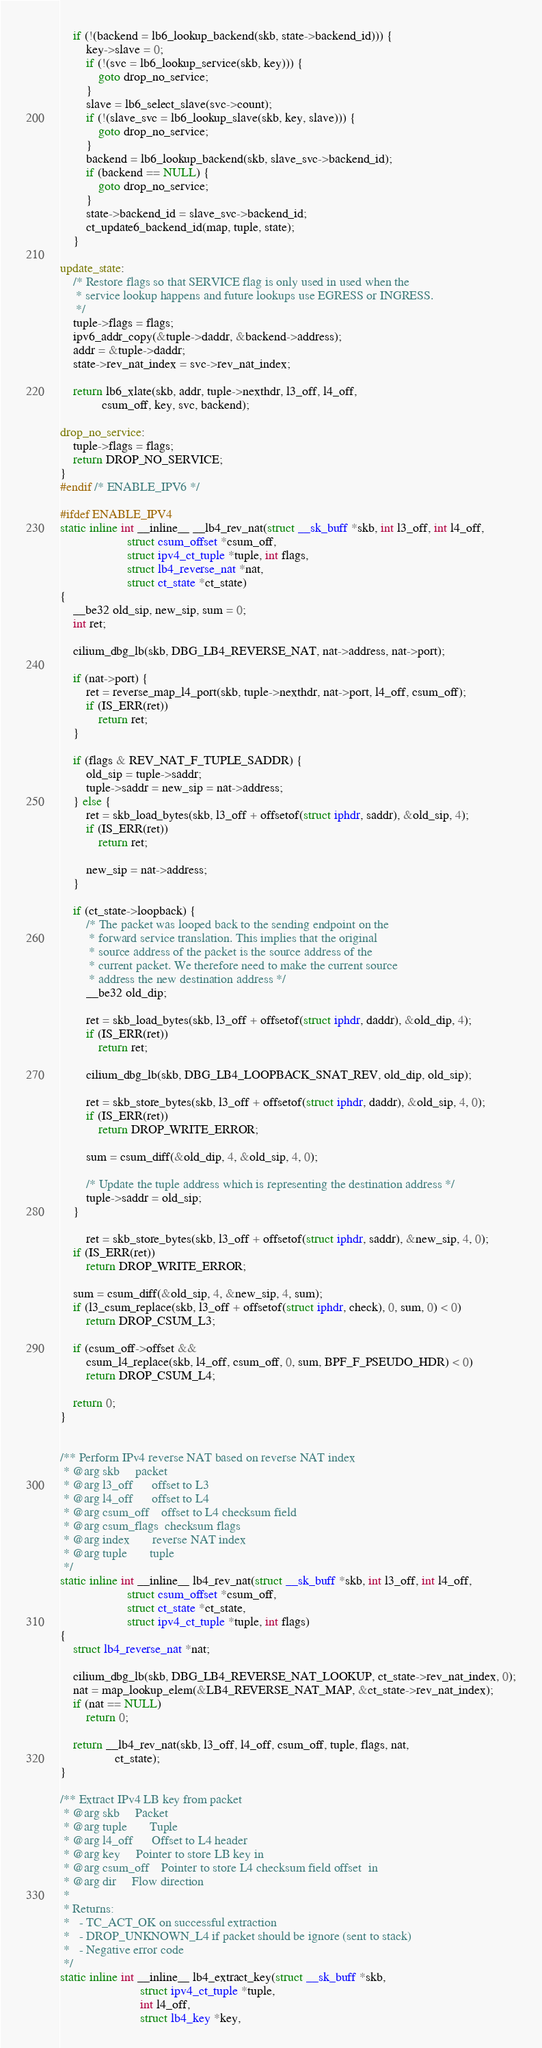<code> <loc_0><loc_0><loc_500><loc_500><_C_>	if (!(backend = lb6_lookup_backend(skb, state->backend_id))) {
		key->slave = 0;
		if (!(svc = lb6_lookup_service(skb, key))) {
			goto drop_no_service;
		}
		slave = lb6_select_slave(svc->count);
		if (!(slave_svc = lb6_lookup_slave(skb, key, slave))) {
			goto drop_no_service;
		}
		backend = lb6_lookup_backend(skb, slave_svc->backend_id);
		if (backend == NULL) {
			goto drop_no_service;
		}
		state->backend_id = slave_svc->backend_id;
		ct_update6_backend_id(map, tuple, state);
	}

update_state:
	/* Restore flags so that SERVICE flag is only used in used when the
	 * service lookup happens and future lookups use EGRESS or INGRESS.
	 */
	tuple->flags = flags;
	ipv6_addr_copy(&tuple->daddr, &backend->address);
	addr = &tuple->daddr;
	state->rev_nat_index = svc->rev_nat_index;

	return lb6_xlate(skb, addr, tuple->nexthdr, l3_off, l4_off,
			 csum_off, key, svc, backend);

drop_no_service:
	tuple->flags = flags;
	return DROP_NO_SERVICE;
}
#endif /* ENABLE_IPV6 */

#ifdef ENABLE_IPV4
static inline int __inline__ __lb4_rev_nat(struct __sk_buff *skb, int l3_off, int l4_off,
					 struct csum_offset *csum_off,
					 struct ipv4_ct_tuple *tuple, int flags,
					 struct lb4_reverse_nat *nat,
					 struct ct_state *ct_state)
{
	__be32 old_sip, new_sip, sum = 0;
	int ret;

	cilium_dbg_lb(skb, DBG_LB4_REVERSE_NAT, nat->address, nat->port);

	if (nat->port) {
		ret = reverse_map_l4_port(skb, tuple->nexthdr, nat->port, l4_off, csum_off);
		if (IS_ERR(ret))
			return ret;
	}

	if (flags & REV_NAT_F_TUPLE_SADDR) {
		old_sip = tuple->saddr;
		tuple->saddr = new_sip = nat->address;
	} else {
		ret = skb_load_bytes(skb, l3_off + offsetof(struct iphdr, saddr), &old_sip, 4);
		if (IS_ERR(ret))
			return ret;

		new_sip = nat->address;
	}

	if (ct_state->loopback) {
		/* The packet was looped back to the sending endpoint on the
		 * forward service translation. This implies that the original
		 * source address of the packet is the source address of the
		 * current packet. We therefore need to make the current source
		 * address the new destination address */
		__be32 old_dip;

		ret = skb_load_bytes(skb, l3_off + offsetof(struct iphdr, daddr), &old_dip, 4);
		if (IS_ERR(ret))
			return ret;

		cilium_dbg_lb(skb, DBG_LB4_LOOPBACK_SNAT_REV, old_dip, old_sip);

		ret = skb_store_bytes(skb, l3_off + offsetof(struct iphdr, daddr), &old_sip, 4, 0);
		if (IS_ERR(ret))
			return DROP_WRITE_ERROR;

		sum = csum_diff(&old_dip, 4, &old_sip, 4, 0);

		/* Update the tuple address which is representing the destination address */
		tuple->saddr = old_sip;
	}

        ret = skb_store_bytes(skb, l3_off + offsetof(struct iphdr, saddr), &new_sip, 4, 0);
	if (IS_ERR(ret))
		return DROP_WRITE_ERROR;

	sum = csum_diff(&old_sip, 4, &new_sip, 4, sum);
	if (l3_csum_replace(skb, l3_off + offsetof(struct iphdr, check), 0, sum, 0) < 0)
		return DROP_CSUM_L3;

	if (csum_off->offset &&
	    csum_l4_replace(skb, l4_off, csum_off, 0, sum, BPF_F_PSEUDO_HDR) < 0)
		return DROP_CSUM_L4;

	return 0;
}


/** Perform IPv4 reverse NAT based on reverse NAT index
 * @arg skb		packet
 * @arg l3_off		offset to L3
 * @arg l4_off		offset to L4
 * @arg csum_off	offset to L4 checksum field
 * @arg csum_flags	checksum flags
 * @arg index		reverse NAT index
 * @arg tuple		tuple
 */
static inline int __inline__ lb4_rev_nat(struct __sk_buff *skb, int l3_off, int l4_off,
					 struct csum_offset *csum_off,
					 struct ct_state *ct_state,
					 struct ipv4_ct_tuple *tuple, int flags)
{
	struct lb4_reverse_nat *nat;

	cilium_dbg_lb(skb, DBG_LB4_REVERSE_NAT_LOOKUP, ct_state->rev_nat_index, 0);
	nat = map_lookup_elem(&LB4_REVERSE_NAT_MAP, &ct_state->rev_nat_index);
	if (nat == NULL)
		return 0;

	return __lb4_rev_nat(skb, l3_off, l4_off, csum_off, tuple, flags, nat,
			     ct_state);
}

/** Extract IPv4 LB key from packet
 * @arg skb		Packet
 * @arg tuple		Tuple
 * @arg l4_off		Offset to L4 header
 * @arg key		Pointer to store LB key in
 * @arg csum_off	Pointer to store L4 checksum field offset  in
 * @arg dir		Flow direction
 *
 * Returns:
 *   - TC_ACT_OK on successful extraction
 *   - DROP_UNKNOWN_L4 if packet should be ignore (sent to stack)
 *   - Negative error code
 */
static inline int __inline__ lb4_extract_key(struct __sk_buff *skb,
					     struct ipv4_ct_tuple *tuple,
					     int l4_off,
					     struct lb4_key *key,</code> 